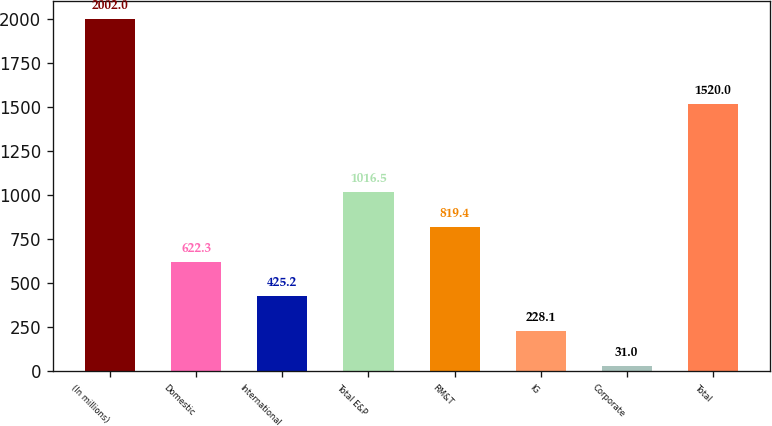Convert chart. <chart><loc_0><loc_0><loc_500><loc_500><bar_chart><fcel>(In millions)<fcel>Domestic<fcel>International<fcel>Total E&P<fcel>RM&T<fcel>IG<fcel>Corporate<fcel>Total<nl><fcel>2002<fcel>622.3<fcel>425.2<fcel>1016.5<fcel>819.4<fcel>228.1<fcel>31<fcel>1520<nl></chart> 